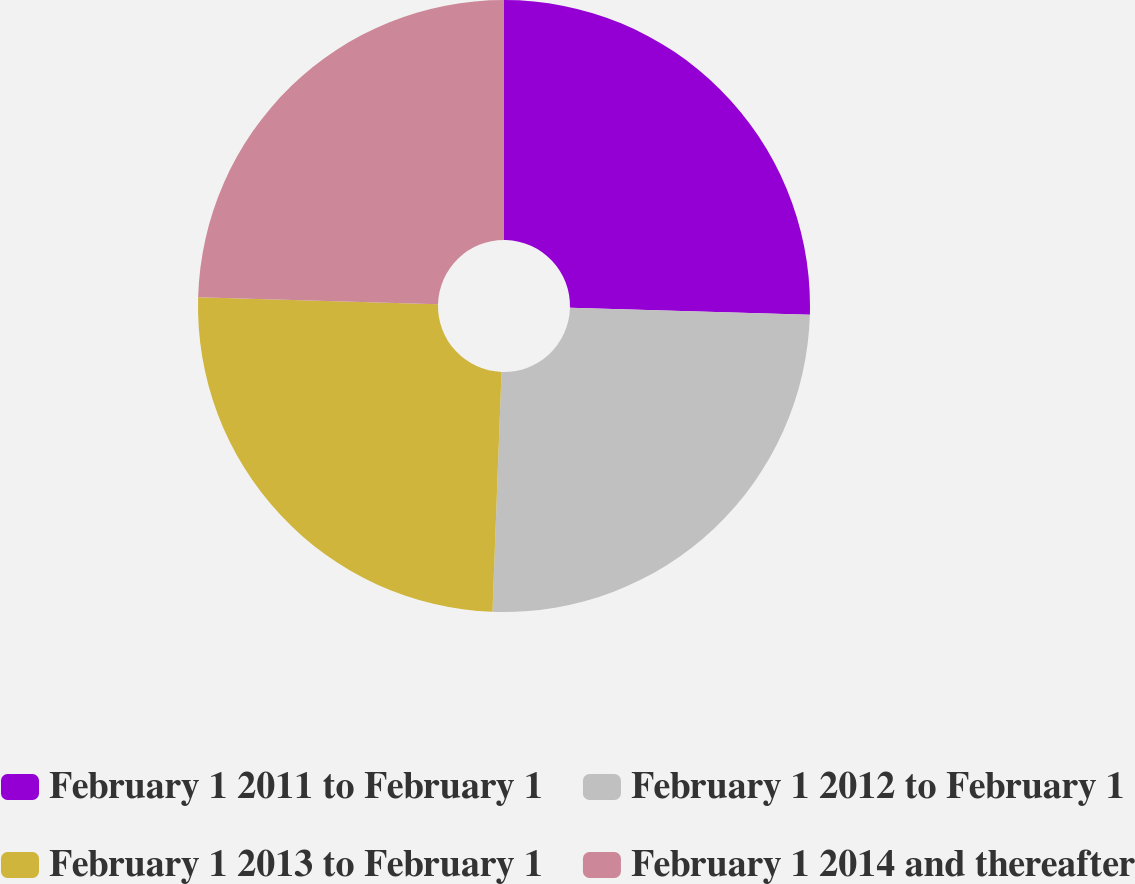Convert chart to OTSL. <chart><loc_0><loc_0><loc_500><loc_500><pie_chart><fcel>February 1 2011 to February 1<fcel>February 1 2012 to February 1<fcel>February 1 2013 to February 1<fcel>February 1 2014 and thereafter<nl><fcel>25.45%<fcel>25.15%<fcel>24.85%<fcel>24.55%<nl></chart> 